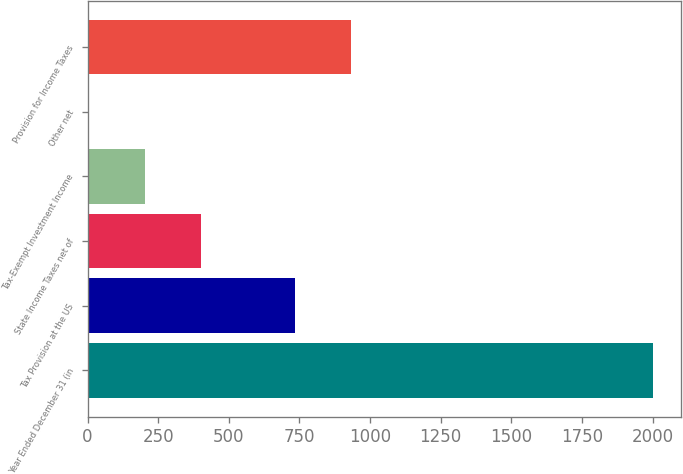<chart> <loc_0><loc_0><loc_500><loc_500><bar_chart><fcel>Year Ended December 31 (in<fcel>Tax Provision at the US<fcel>State Income Taxes net of<fcel>Tax-Exempt Investment Income<fcel>Other net<fcel>Provision for Income Taxes<nl><fcel>2002<fcel>734<fcel>402.8<fcel>202.9<fcel>3<fcel>933.9<nl></chart> 